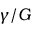Convert formula to latex. <formula><loc_0><loc_0><loc_500><loc_500>\gamma / G</formula> 